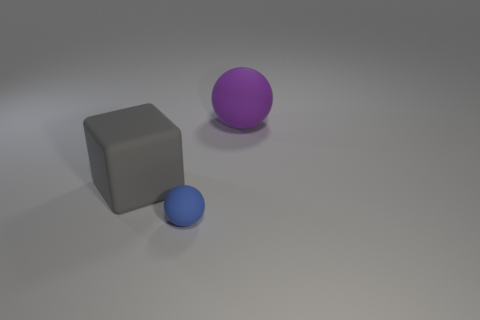Add 3 gray matte blocks. How many objects exist? 6 Subtract all cubes. How many objects are left? 2 Subtract all gray cylinders. Subtract all purple spheres. How many objects are left? 2 Add 1 blue rubber balls. How many blue rubber balls are left? 2 Add 1 gray rubber cubes. How many gray rubber cubes exist? 2 Subtract 1 purple spheres. How many objects are left? 2 